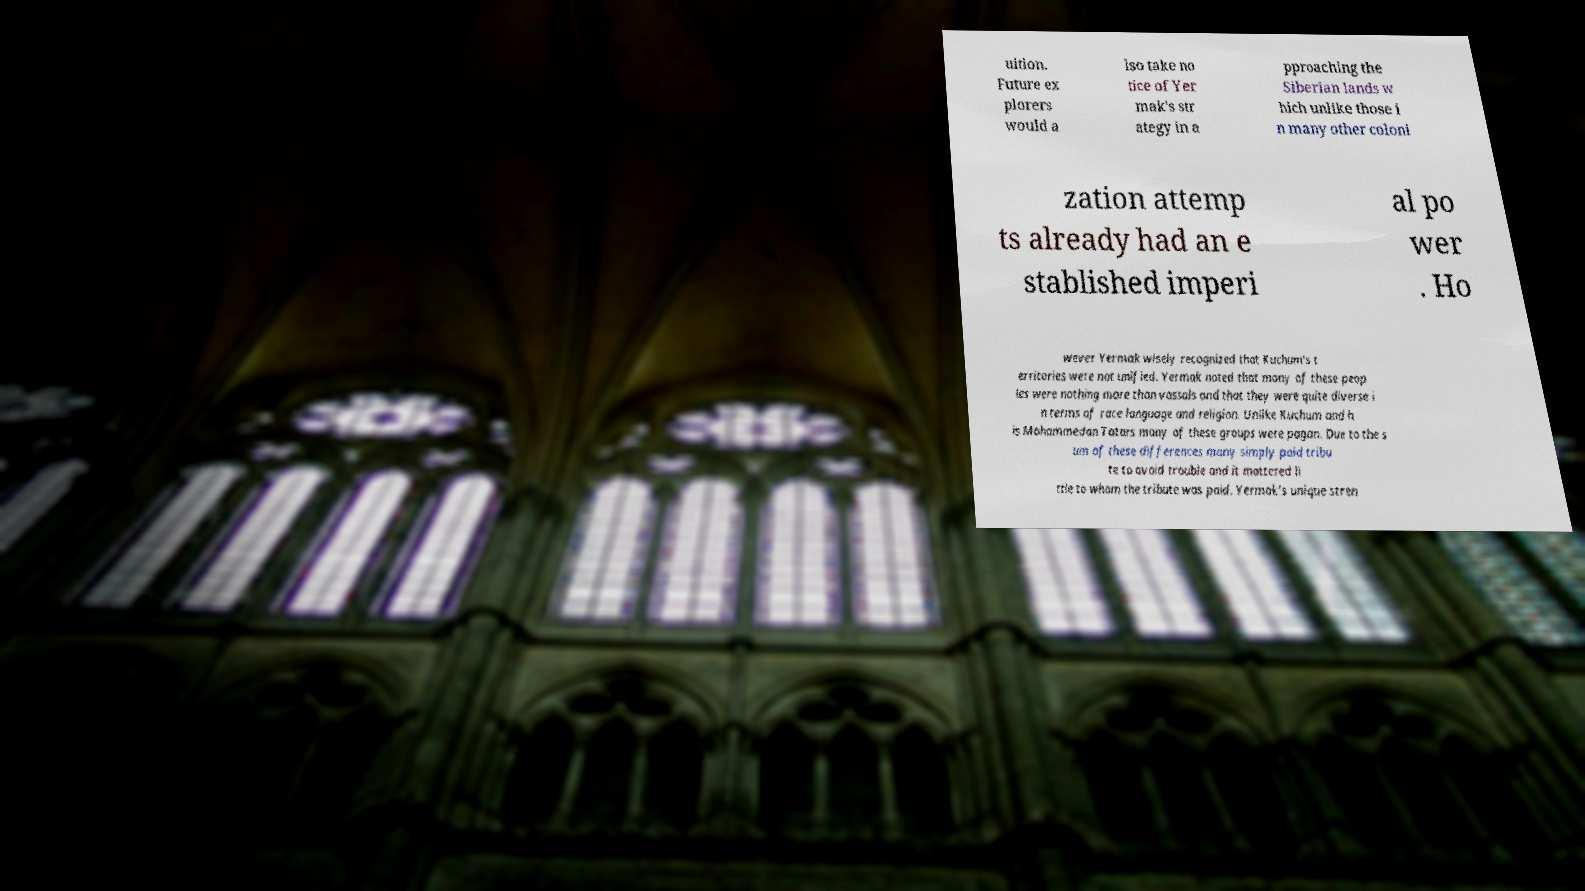Can you accurately transcribe the text from the provided image for me? uition. Future ex plorers would a lso take no tice of Yer mak's str ategy in a pproaching the Siberian lands w hich unlike those i n many other coloni zation attemp ts already had an e stablished imperi al po wer . Ho wever Yermak wisely recognized that Kuchum's t erritories were not unified. Yermak noted that many of these peop les were nothing more than vassals and that they were quite diverse i n terms of race language and religion. Unlike Kuchum and h is Mohammedan Tatars many of these groups were pagan. Due to the s um of these differences many simply paid tribu te to avoid trouble and it mattered li ttle to whom the tribute was paid. Yermak's unique stren 